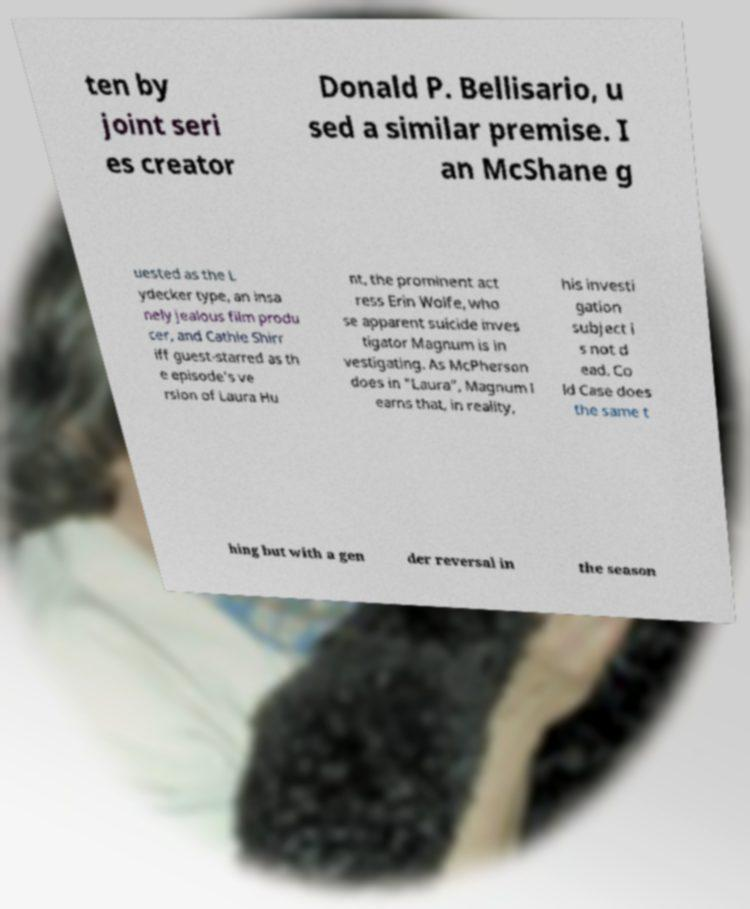Please identify and transcribe the text found in this image. ten by joint seri es creator Donald P. Bellisario, u sed a similar premise. I an McShane g uested as the L ydecker type, an insa nely jealous film produ cer, and Cathie Shirr iff guest-starred as th e episode's ve rsion of Laura Hu nt, the prominent act ress Erin Wolfe, who se apparent suicide inves tigator Magnum is in vestigating. As McPherson does in "Laura", Magnum l earns that, in reality, his investi gation subject i s not d ead. Co ld Case does the same t hing but with a gen der reversal in the season 